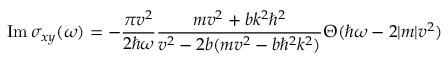<formula> <loc_0><loc_0><loc_500><loc_500>I m \, \sigma _ { x y } ( \omega ) = - \frac { \pi v ^ { 2 } } { 2 \hbar { \omega } } \frac { m v ^ { 2 } + b k ^ { 2 } \hbar { ^ } { 2 } } { v ^ { 2 } - 2 b ( m v ^ { 2 } - b \hbar { ^ } { 2 } k ^ { 2 } ) } \Theta ( \hbar { \omega } - 2 | m | v ^ { 2 } )</formula> 